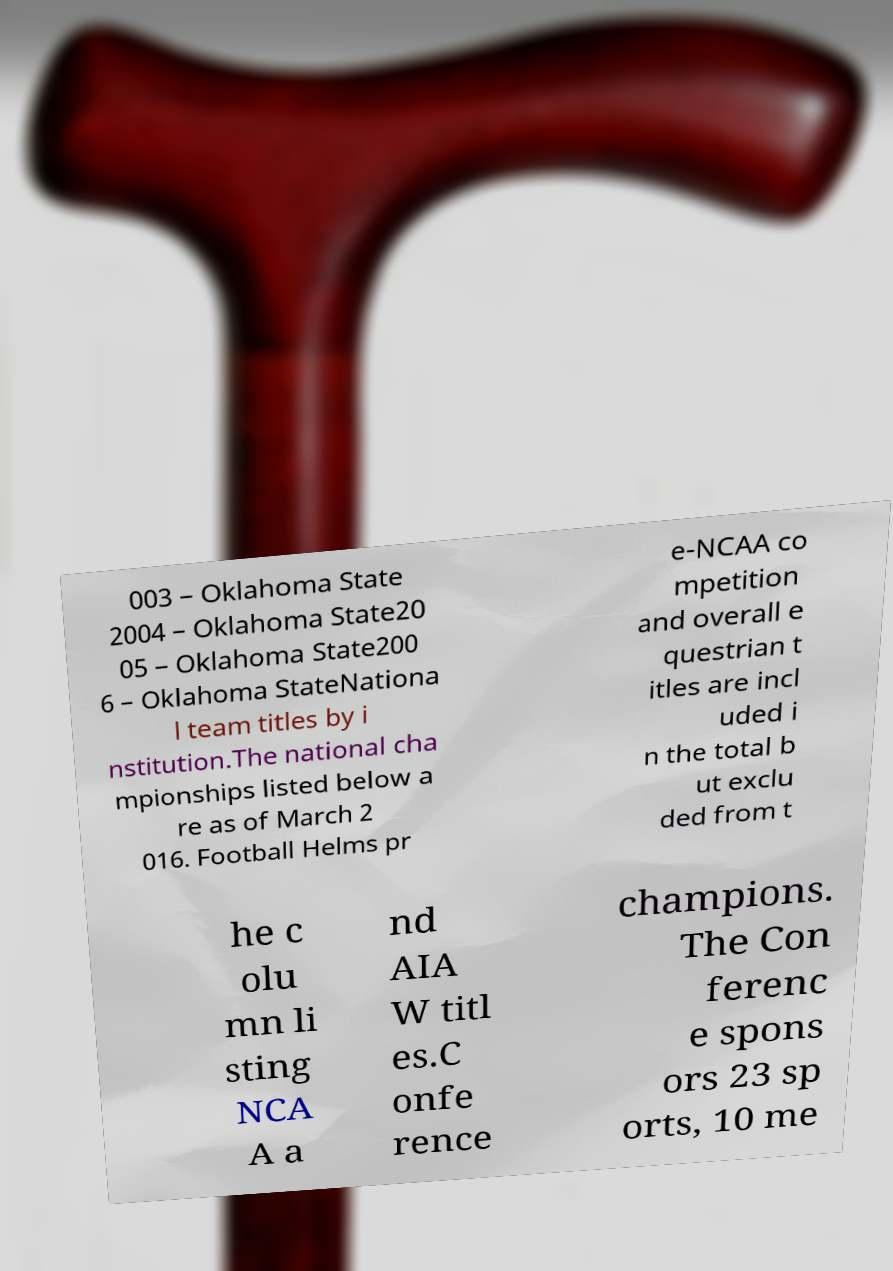What messages or text are displayed in this image? I need them in a readable, typed format. 003 – Oklahoma State 2004 – Oklahoma State20 05 – Oklahoma State200 6 – Oklahoma StateNationa l team titles by i nstitution.The national cha mpionships listed below a re as of March 2 016. Football Helms pr e-NCAA co mpetition and overall e questrian t itles are incl uded i n the total b ut exclu ded from t he c olu mn li sting NCA A a nd AIA W titl es.C onfe rence champions. The Con ferenc e spons ors 23 sp orts, 10 me 